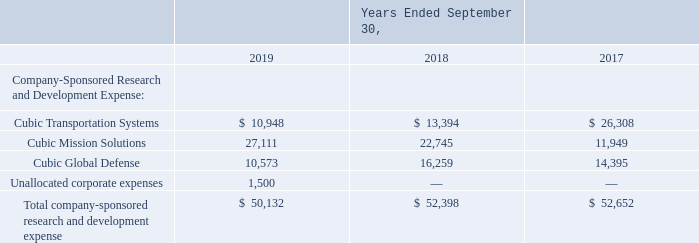Strategic Innovation-focused Investment of Capital
We target markets that have the potential for above-average growth and profit margins where domain expertise, innovation, technical competency and contracting dynamics can help to create meaningful barriers to entry. We will strategically reinvest our cash in key program captures, internal research and development (R&D), and acquisitions to target priority markets and help ensure market leading positions to drive long-term shareholder return.
We are committed to using innovation and technology to address our customers’ most pressing problems and demanding requirements. We have made meaningful and recognized contributions to technological advancements within our industries.
The cost of company-sponsored R&D activities included in our Consolidated Statements of Operations are as follows (in thousands):
Which markets does the company target? Markets that have the potential for above-average growth and profit margins where domain expertise, innovation, technical competency and contracting dynamics can help to create meaningful barriers to entry. Where will the company strategically reinvest their cash? In key program captures, internal research and development (r&d), and acquisitions to target priority markets and help ensure market leading positions to drive long-term shareholder return. What are the types of company-sponsored R&D activities in the table? Cubic transportation systems, cubic mission solutions, cubic global defense, unallocated corporate expenses. How many types of company-sponsored R&D activities are there in the table? Cubic Transportation Systems##Cubic Mission Solutions##Cubic Global Defense##Unallocated corporate expenses
Answer: 4. What is the change in the total company-sponsored research and development expense in 2019 from 2018?
Answer scale should be: thousand. 50,132-52,398
Answer: -2266. What is the percentage change in Cubic Mission Solutions in 2019 from 2018?
Answer scale should be: percent. (27,111-22,745)/22,745
Answer: 19.2. 